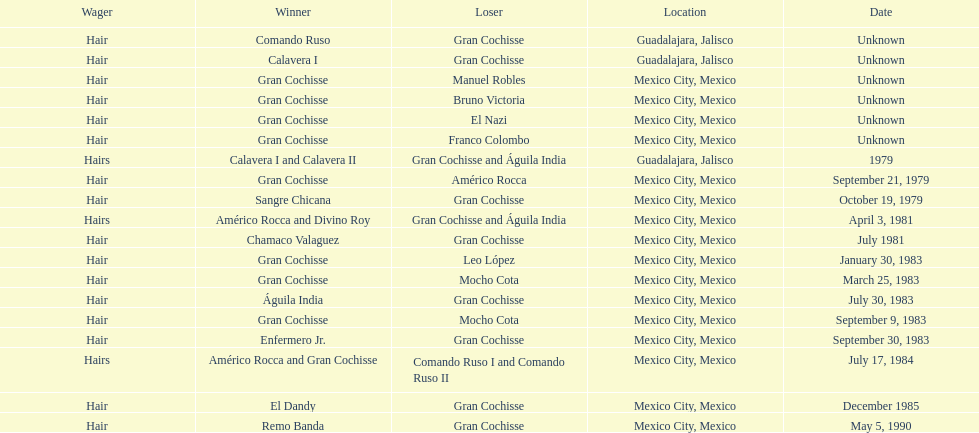What was the number of losses gran cochisse had against el dandy? 1. 